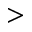<formula> <loc_0><loc_0><loc_500><loc_500>></formula> 